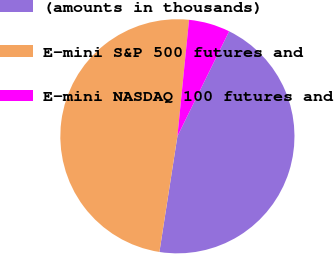Convert chart. <chart><loc_0><loc_0><loc_500><loc_500><pie_chart><fcel>(amounts in thousands)<fcel>E-mini S&P 500 futures and<fcel>E-mini NASDAQ 100 futures and<nl><fcel>45.17%<fcel>49.13%<fcel>5.7%<nl></chart> 